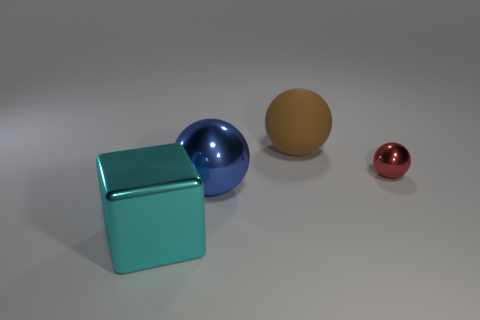What number of other objects are the same shape as the brown matte object?
Provide a short and direct response. 2. What shape is the big brown object?
Make the answer very short. Sphere. Does the red sphere have the same material as the brown object?
Your response must be concise. No. Are there an equal number of large balls on the left side of the block and large metal blocks that are to the right of the big blue thing?
Keep it short and to the point. Yes. Is there a ball that is to the left of the big thing that is to the right of the ball in front of the tiny red ball?
Give a very brief answer. Yes. Is the metal block the same size as the rubber thing?
Your answer should be compact. Yes. There is a big shiny object left of the large ball on the left side of the large sphere behind the small metal object; what color is it?
Ensure brevity in your answer.  Cyan. What number of big objects are either gray cubes or brown matte things?
Ensure brevity in your answer.  1. Are there any tiny gray metallic things that have the same shape as the red shiny thing?
Provide a succinct answer. No. Does the big blue thing have the same shape as the cyan thing?
Your answer should be compact. No. 